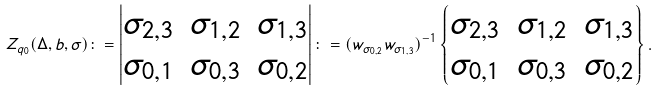<formula> <loc_0><loc_0><loc_500><loc_500>Z _ { q _ { 0 } } ( \Delta , b , \sigma ) \colon = \begin{vmatrix} \sigma _ { 2 , 3 } & \sigma _ { 1 , 2 } & \sigma _ { 1 , 3 } \\ \sigma _ { 0 , 1 } & \sigma _ { 0 , 3 } & \sigma _ { 0 , 2 } \end{vmatrix} \colon = ( w _ { \sigma _ { 0 , 2 } } w _ { \sigma _ { 1 , 3 } } ) ^ { - 1 } \begin{Bmatrix} \sigma _ { 2 , 3 } & \sigma _ { 1 , 2 } & \sigma _ { 1 , 3 } \\ \sigma _ { 0 , 1 } & \sigma _ { 0 , 3 } & \sigma _ { 0 , 2 } \end{Bmatrix} .</formula> 